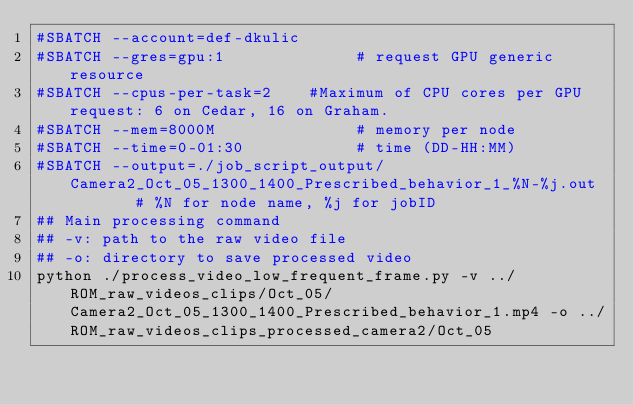Convert code to text. <code><loc_0><loc_0><loc_500><loc_500><_Bash_>#SBATCH --account=def-dkulic
#SBATCH --gres=gpu:1              # request GPU generic resource
#SBATCH --cpus-per-task=2    #Maximum of CPU cores per GPU request: 6 on Cedar, 16 on Graham.
#SBATCH --mem=8000M               # memory per node
#SBATCH --time=0-01:30            # time (DD-HH:MM)
#SBATCH --output=./job_script_output/Camera2_Oct_05_1300_1400_Prescribed_behavior_1_%N-%j.out        # %N for node name, %j for jobID
## Main processing command
## -v: path to the raw video file
## -o: directory to save processed video
python ./process_video_low_frequent_frame.py -v ../ROM_raw_videos_clips/Oct_05/Camera2_Oct_05_1300_1400_Prescribed_behavior_1.mp4 -o ../ROM_raw_videos_clips_processed_camera2/Oct_05
</code> 